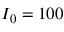<formula> <loc_0><loc_0><loc_500><loc_500>I _ { 0 } = 1 0 0</formula> 